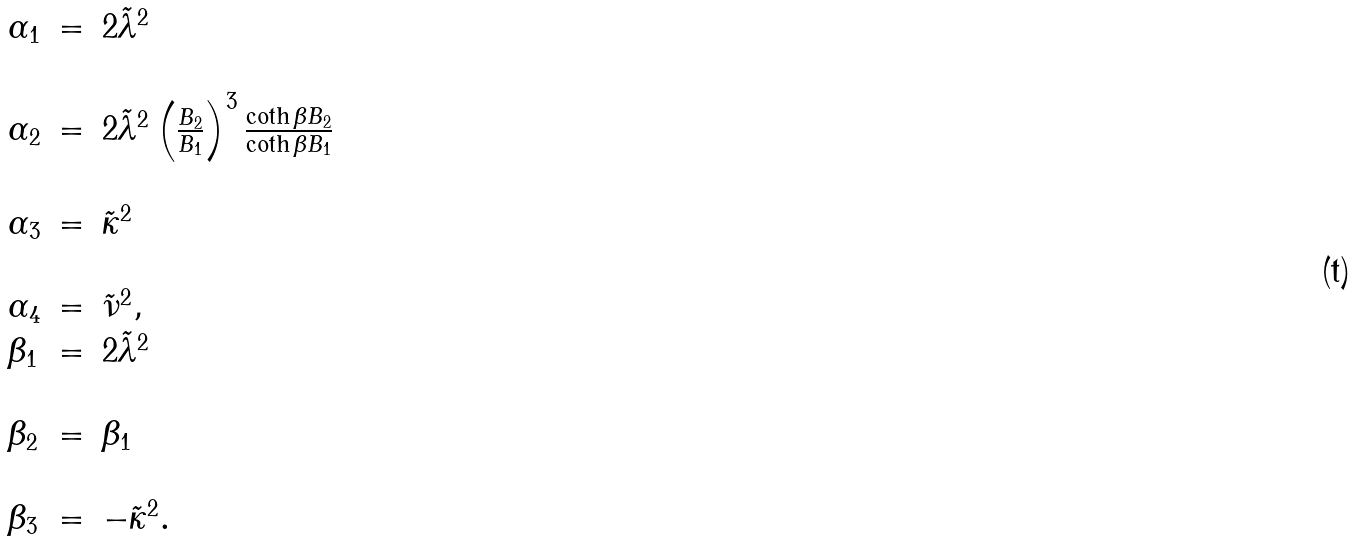Convert formula to latex. <formula><loc_0><loc_0><loc_500><loc_500>\begin{array} { l l l } \alpha _ { 1 } & = & 2 \tilde { \lambda } ^ { 2 } \\ & & \\ \alpha _ { 2 } & = & 2 \tilde { \lambda } ^ { 2 } \left ( \frac { B _ { 2 } } { B _ { 1 } } \right ) ^ { 3 } \frac { \coth \beta B _ { 2 } } { \coth \beta B _ { 1 } } \\ & & \\ \alpha _ { 3 } & = & \tilde { \kappa } ^ { 2 } \\ & & \\ \alpha _ { 4 } & = & \tilde { \nu } ^ { 2 } , \\ \beta _ { 1 } & = & 2 \tilde { \lambda } ^ { 2 } \\ & & \\ \beta _ { 2 } & = & \beta _ { 1 } \\ & & \\ \beta _ { 3 } & = & - \tilde { \kappa } ^ { 2 } . \end{array}</formula> 